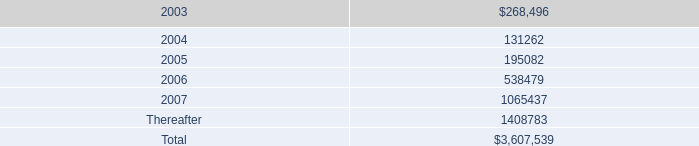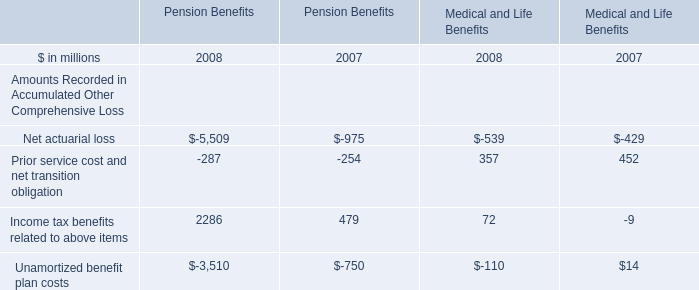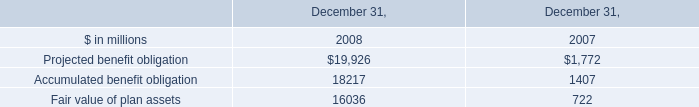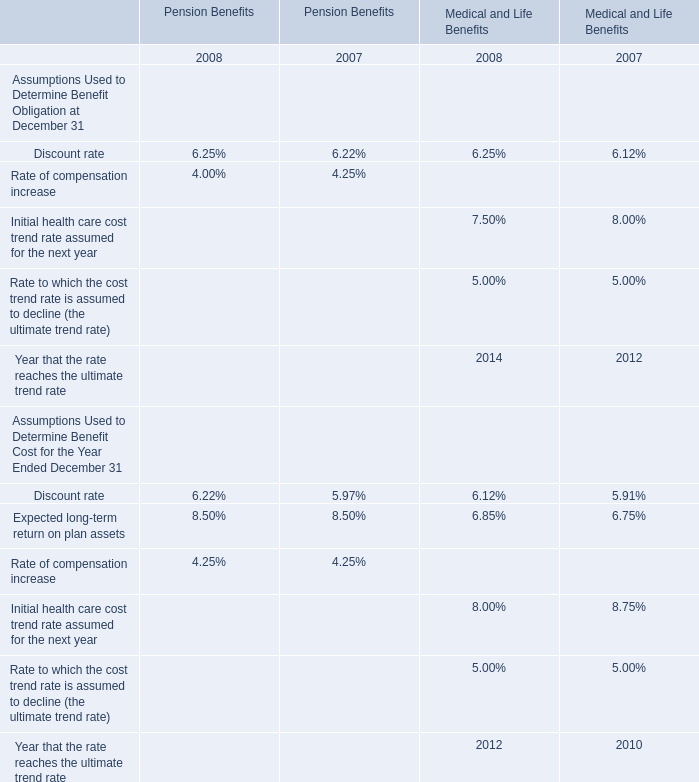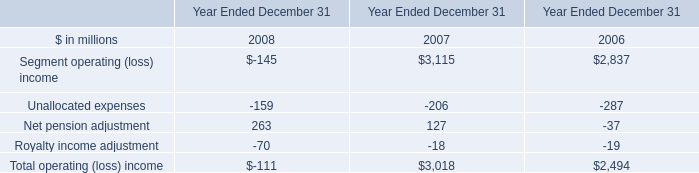of the amount agreed by the company for the prepayment on the term loans what was the percentage for the term loan a 
Computations: (75.0 / 200.0)
Answer: 0.375. 